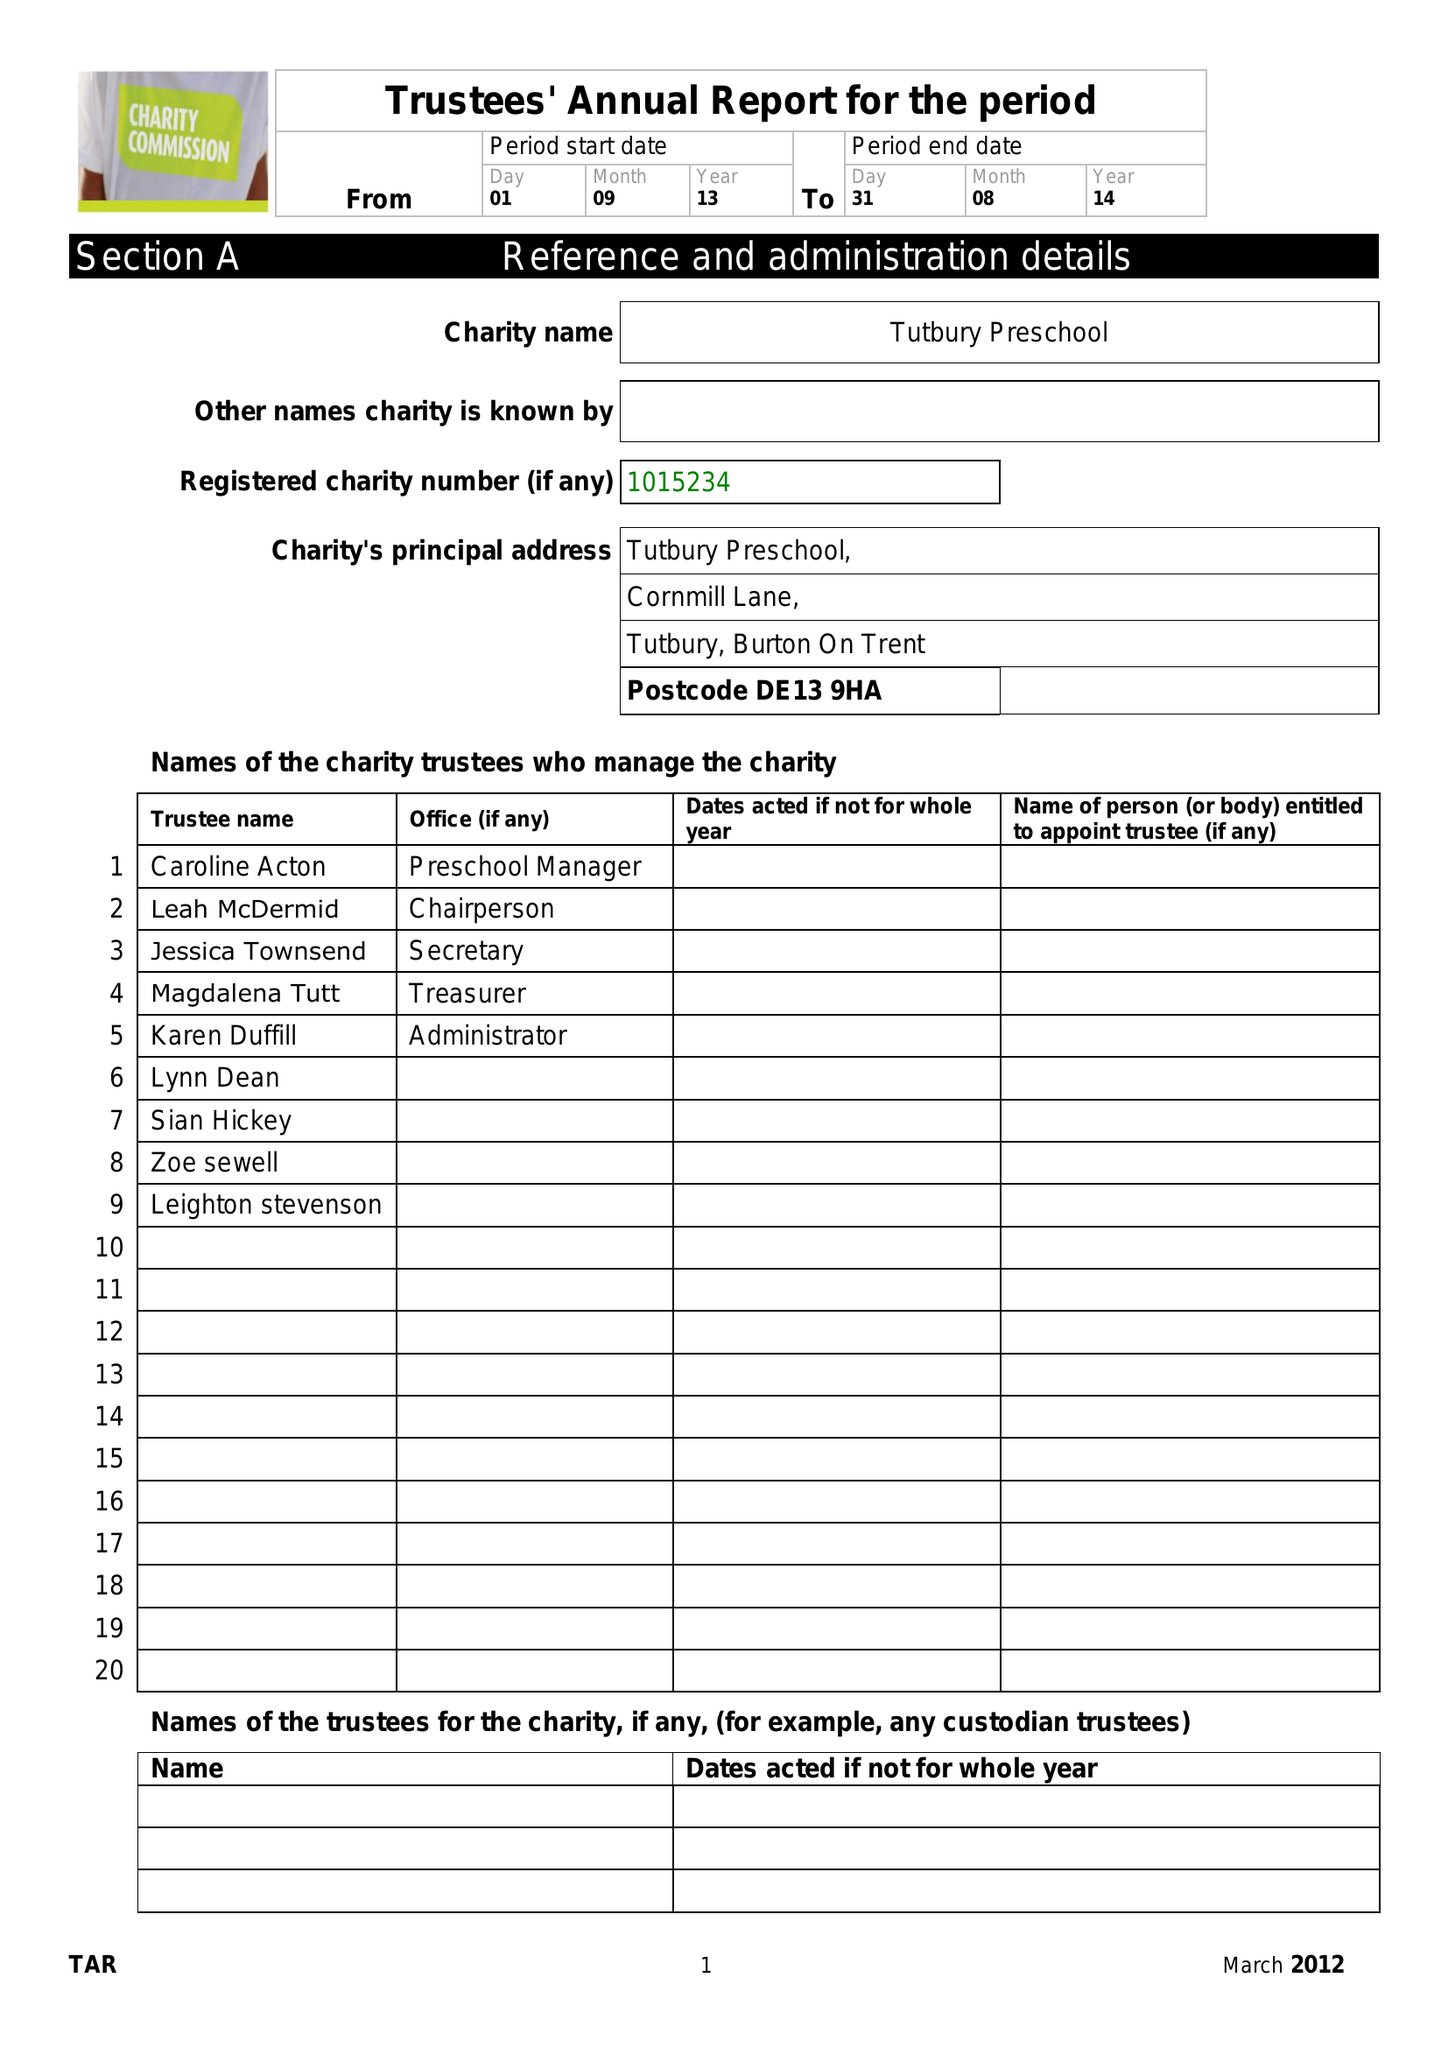What is the value for the charity_number?
Answer the question using a single word or phrase. 1015234 